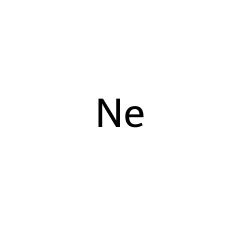What element is represented in this SMILES notation? The SMILES notation [Ne] indicates the presence of neon gas. The notation specifically identifies the element based on its chemical symbol.
Answer: neon How many atoms are in this chemical structure? The SMILES representation [Ne] signifies a single atom of neon. This indicates that there is only one atom present, as represented by the lack of surrounding elements or bonds in the notation.
Answer: one Is this chemical a noble gas? The element shown in the SMILES notation, neon, is classified as a noble gas. Noble gases are characterized by their full valence electron shells, making them stable and largely unreactive.
Answer: yes What is the state of matter for this chemical at room temperature? Neon exists as a gas at room temperature. The properties of noble gases reveal that they generally are gaseous under standard conditions.
Answer: gas Can this element form bonds with other atoms? Neon is known for being inert, meaning it does not typically form chemical bonds with other elements. It has a stable electron configuration that does not require it to bond with others.
Answer: no Does this chemical emit light when electrified? Neon gas emits a characteristic bright glow when an electrical current passes through it, a property utilized in neon signs. This phenomenon is due to the excitation of its electrons.
Answer: yes 